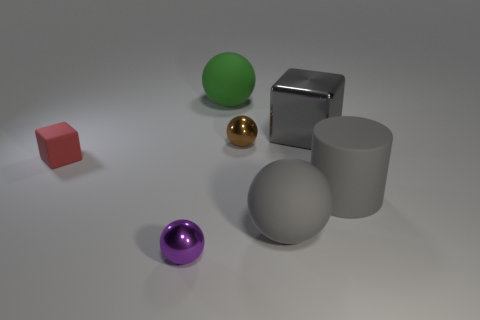Add 1 large brown matte balls. How many objects exist? 8 Subtract all brown balls. How many balls are left? 3 Subtract 2 spheres. How many spheres are left? 2 Subtract all cylinders. How many objects are left? 6 Subtract all green balls. How many balls are left? 3 Add 5 red matte objects. How many red matte objects exist? 6 Subtract 1 red cubes. How many objects are left? 6 Subtract all green blocks. Subtract all red cylinders. How many blocks are left? 2 Subtract all tiny red rubber objects. Subtract all purple balls. How many objects are left? 5 Add 5 gray metallic cubes. How many gray metallic cubes are left? 6 